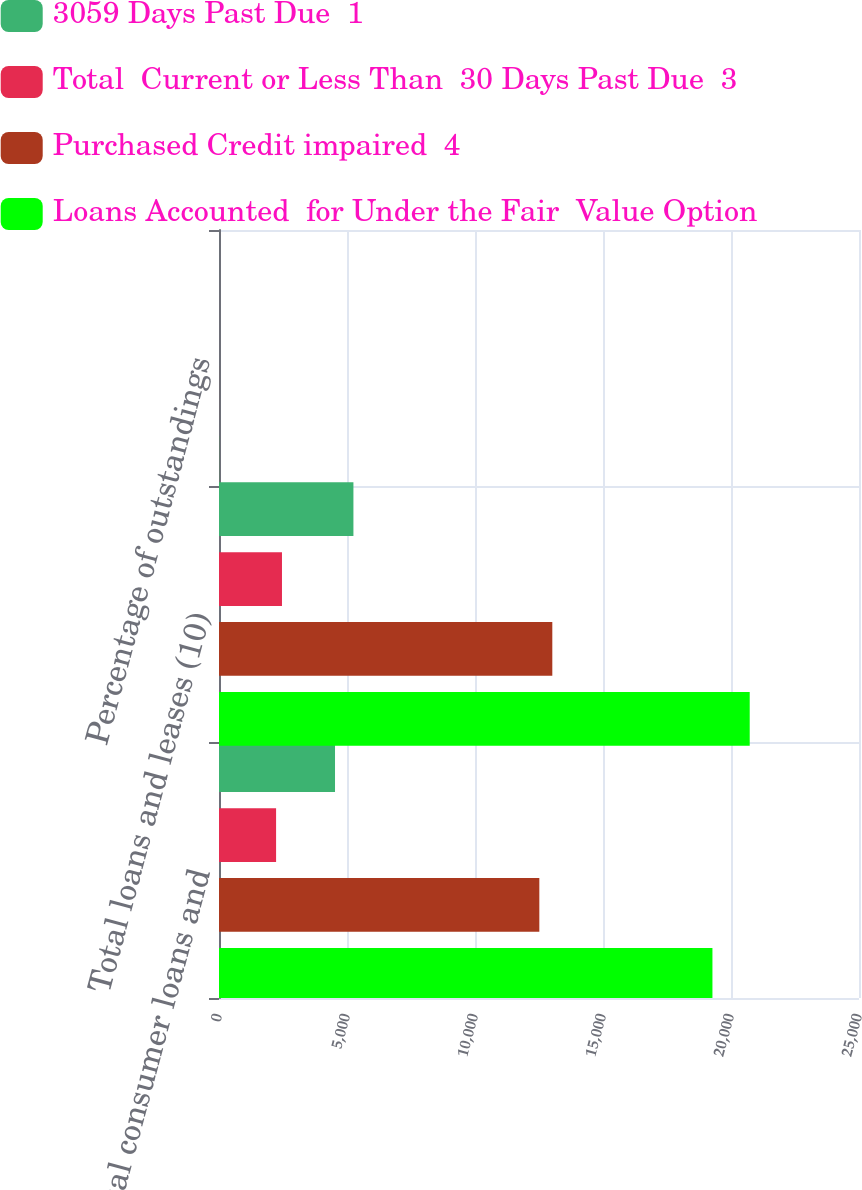<chart> <loc_0><loc_0><loc_500><loc_500><stacked_bar_chart><ecel><fcel>Total consumer loans and<fcel>Total loans and leases (10)<fcel>Percentage of outstandings<nl><fcel>3059 Days Past Due  1<fcel>4532<fcel>5251<fcel>0.59<nl><fcel>Total  Current or Less Than  30 Days Past Due  3<fcel>2230<fcel>2460<fcel>0.27<nl><fcel>Purchased Credit impaired  4<fcel>12513<fcel>13020<fcel>1.45<nl><fcel>Loans Accounted  for Under the Fair  Value Option<fcel>19275<fcel>20731<fcel>2.31<nl></chart> 